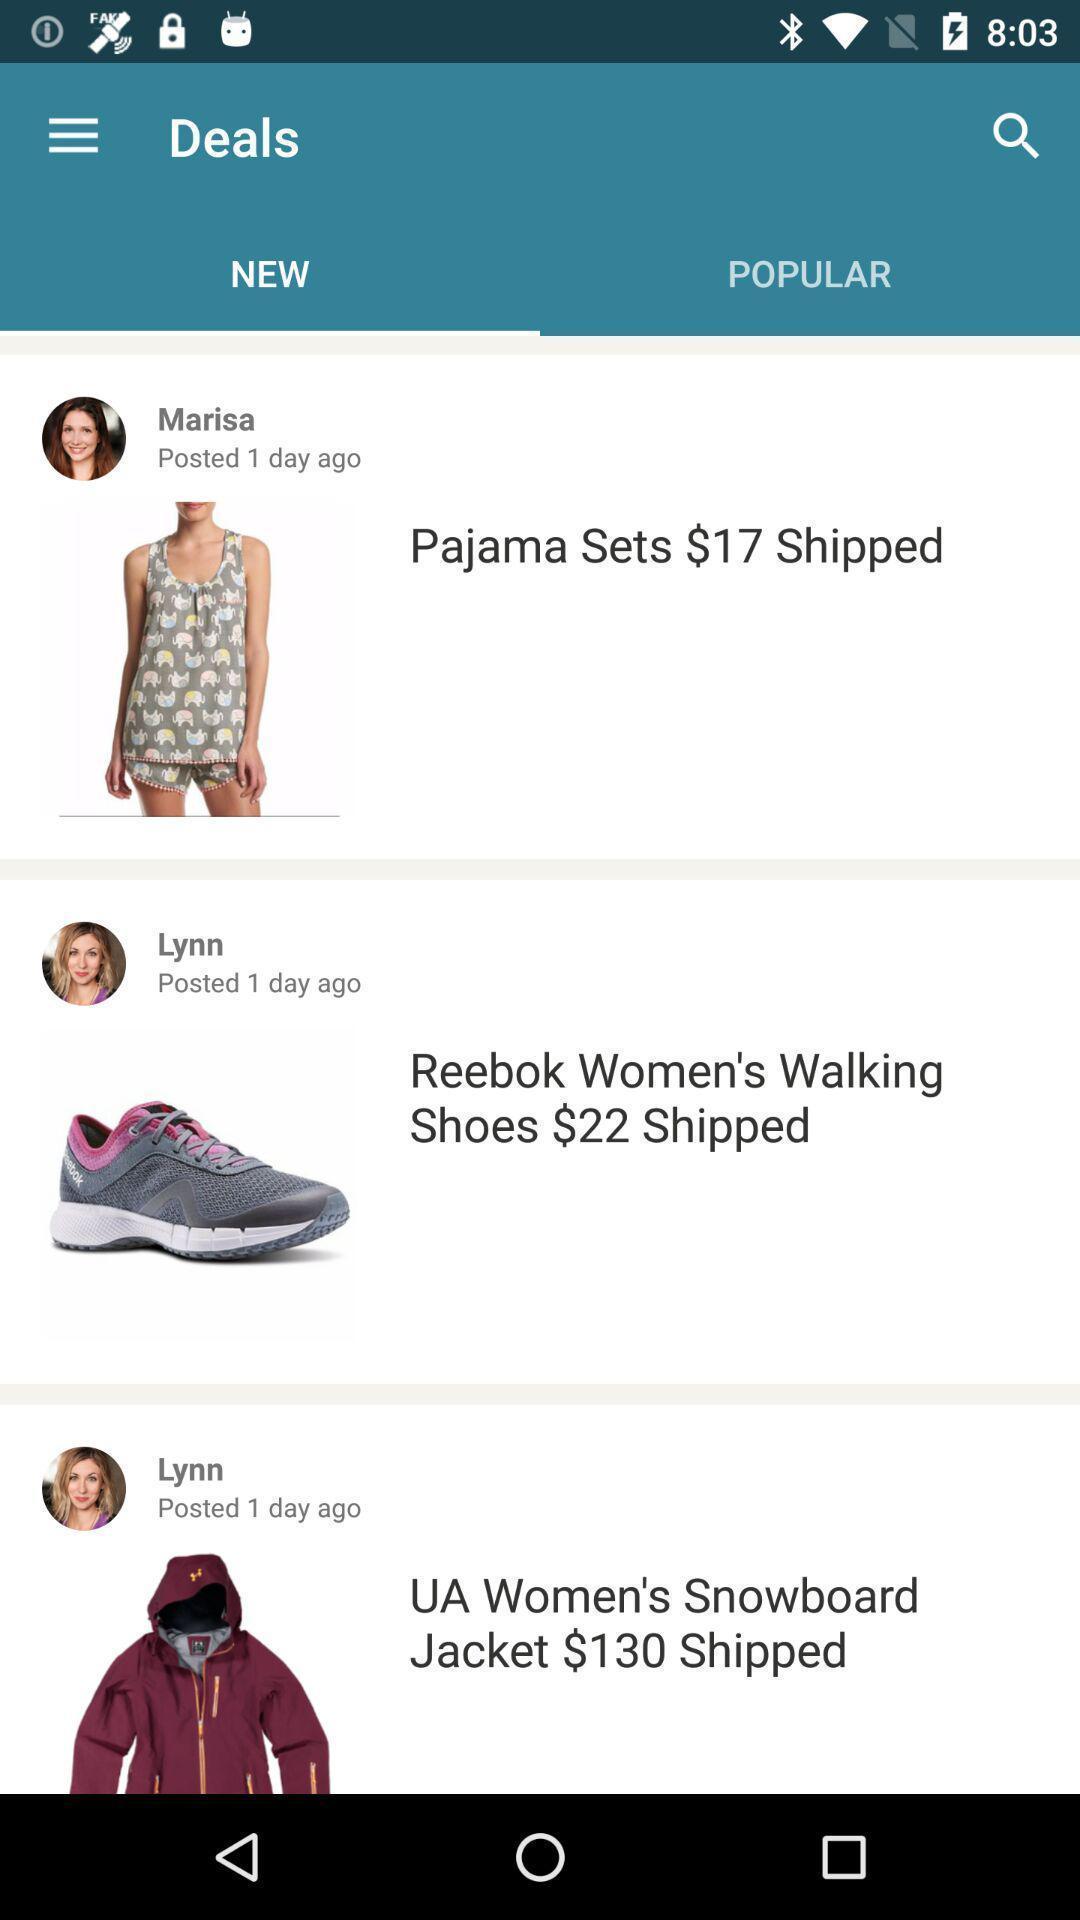Provide a detailed account of this screenshot. Screen shows new deals in the shopping app. 